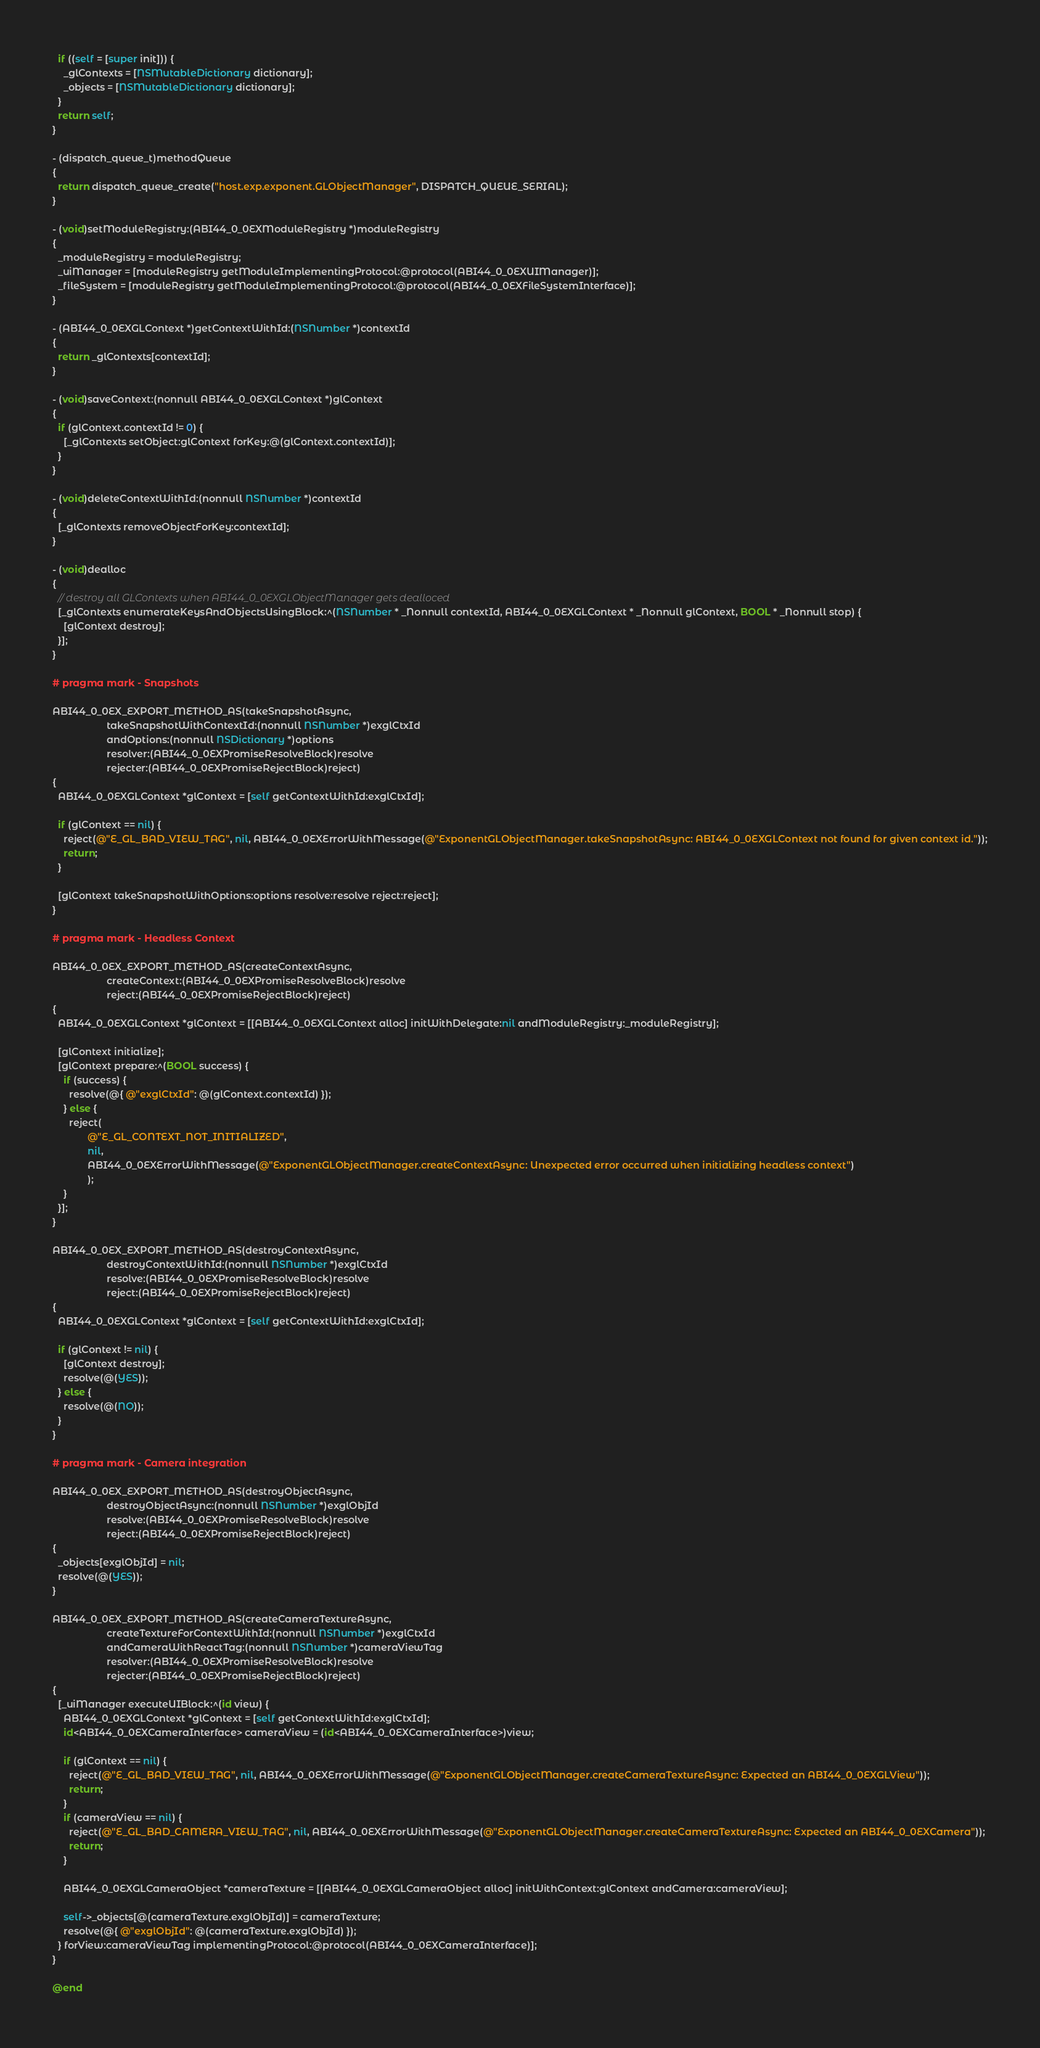Convert code to text. <code><loc_0><loc_0><loc_500><loc_500><_ObjectiveC_>  if ((self = [super init])) {
    _glContexts = [NSMutableDictionary dictionary];
    _objects = [NSMutableDictionary dictionary];
  }
  return self;
}

- (dispatch_queue_t)methodQueue
{
  return dispatch_queue_create("host.exp.exponent.GLObjectManager", DISPATCH_QUEUE_SERIAL);
}

- (void)setModuleRegistry:(ABI44_0_0EXModuleRegistry *)moduleRegistry
{
  _moduleRegistry = moduleRegistry;
  _uiManager = [moduleRegistry getModuleImplementingProtocol:@protocol(ABI44_0_0EXUIManager)];
  _fileSystem = [moduleRegistry getModuleImplementingProtocol:@protocol(ABI44_0_0EXFileSystemInterface)];
}

- (ABI44_0_0EXGLContext *)getContextWithId:(NSNumber *)contextId
{
  return _glContexts[contextId];
}

- (void)saveContext:(nonnull ABI44_0_0EXGLContext *)glContext
{
  if (glContext.contextId != 0) {
    [_glContexts setObject:glContext forKey:@(glContext.contextId)];
  }
}

- (void)deleteContextWithId:(nonnull NSNumber *)contextId
{
  [_glContexts removeObjectForKey:contextId];
}

- (void)dealloc
{
  // destroy all GLContexts when ABI44_0_0EXGLObjectManager gets dealloced
  [_glContexts enumerateKeysAndObjectsUsingBlock:^(NSNumber * _Nonnull contextId, ABI44_0_0EXGLContext * _Nonnull glContext, BOOL * _Nonnull stop) {
    [glContext destroy];
  }];
}

# pragma mark - Snapshots

ABI44_0_0EX_EXPORT_METHOD_AS(takeSnapshotAsync,
                    takeSnapshotWithContextId:(nonnull NSNumber *)exglCtxId
                    andOptions:(nonnull NSDictionary *)options
                    resolver:(ABI44_0_0EXPromiseResolveBlock)resolve
                    rejecter:(ABI44_0_0EXPromiseRejectBlock)reject)
{
  ABI44_0_0EXGLContext *glContext = [self getContextWithId:exglCtxId];

  if (glContext == nil) {
    reject(@"E_GL_BAD_VIEW_TAG", nil, ABI44_0_0EXErrorWithMessage(@"ExponentGLObjectManager.takeSnapshotAsync: ABI44_0_0EXGLContext not found for given context id."));
    return;
  }

  [glContext takeSnapshotWithOptions:options resolve:resolve reject:reject];
}

# pragma mark - Headless Context

ABI44_0_0EX_EXPORT_METHOD_AS(createContextAsync,
                    createContext:(ABI44_0_0EXPromiseResolveBlock)resolve
                    reject:(ABI44_0_0EXPromiseRejectBlock)reject)
{
  ABI44_0_0EXGLContext *glContext = [[ABI44_0_0EXGLContext alloc] initWithDelegate:nil andModuleRegistry:_moduleRegistry];

  [glContext initialize];
  [glContext prepare:^(BOOL success) {
    if (success) {
      resolve(@{ @"exglCtxId": @(glContext.contextId) });
    } else {
      reject(
             @"E_GL_CONTEXT_NOT_INITIALIZED",
             nil,
             ABI44_0_0EXErrorWithMessage(@"ExponentGLObjectManager.createContextAsync: Unexpected error occurred when initializing headless context")
             );
    }
  }];
}

ABI44_0_0EX_EXPORT_METHOD_AS(destroyContextAsync,
                    destroyContextWithId:(nonnull NSNumber *)exglCtxId
                    resolve:(ABI44_0_0EXPromiseResolveBlock)resolve
                    reject:(ABI44_0_0EXPromiseRejectBlock)reject)
{
  ABI44_0_0EXGLContext *glContext = [self getContextWithId:exglCtxId];

  if (glContext != nil) {
    [glContext destroy];
    resolve(@(YES));
  } else {
    resolve(@(NO));
  }
}

# pragma mark - Camera integration

ABI44_0_0EX_EXPORT_METHOD_AS(destroyObjectAsync,
                    destroyObjectAsync:(nonnull NSNumber *)exglObjId
                    resolve:(ABI44_0_0EXPromiseResolveBlock)resolve
                    reject:(ABI44_0_0EXPromiseRejectBlock)reject)
{
  _objects[exglObjId] = nil;
  resolve(@(YES));
}

ABI44_0_0EX_EXPORT_METHOD_AS(createCameraTextureAsync,
                    createTextureForContextWithId:(nonnull NSNumber *)exglCtxId
                    andCameraWithReactTag:(nonnull NSNumber *)cameraViewTag
                    resolver:(ABI44_0_0EXPromiseResolveBlock)resolve
                    rejecter:(ABI44_0_0EXPromiseRejectBlock)reject)
{
  [_uiManager executeUIBlock:^(id view) {
    ABI44_0_0EXGLContext *glContext = [self getContextWithId:exglCtxId];
    id<ABI44_0_0EXCameraInterface> cameraView = (id<ABI44_0_0EXCameraInterface>)view;

    if (glContext == nil) {
      reject(@"E_GL_BAD_VIEW_TAG", nil, ABI44_0_0EXErrorWithMessage(@"ExponentGLObjectManager.createCameraTextureAsync: Expected an ABI44_0_0EXGLView"));
      return;
    }
    if (cameraView == nil) {
      reject(@"E_GL_BAD_CAMERA_VIEW_TAG", nil, ABI44_0_0EXErrorWithMessage(@"ExponentGLObjectManager.createCameraTextureAsync: Expected an ABI44_0_0EXCamera"));
      return;
    }

    ABI44_0_0EXGLCameraObject *cameraTexture = [[ABI44_0_0EXGLCameraObject alloc] initWithContext:glContext andCamera:cameraView];

    self->_objects[@(cameraTexture.exglObjId)] = cameraTexture;
    resolve(@{ @"exglObjId": @(cameraTexture.exglObjId) });
  } forView:cameraViewTag implementingProtocol:@protocol(ABI44_0_0EXCameraInterface)];
}

@end
</code> 